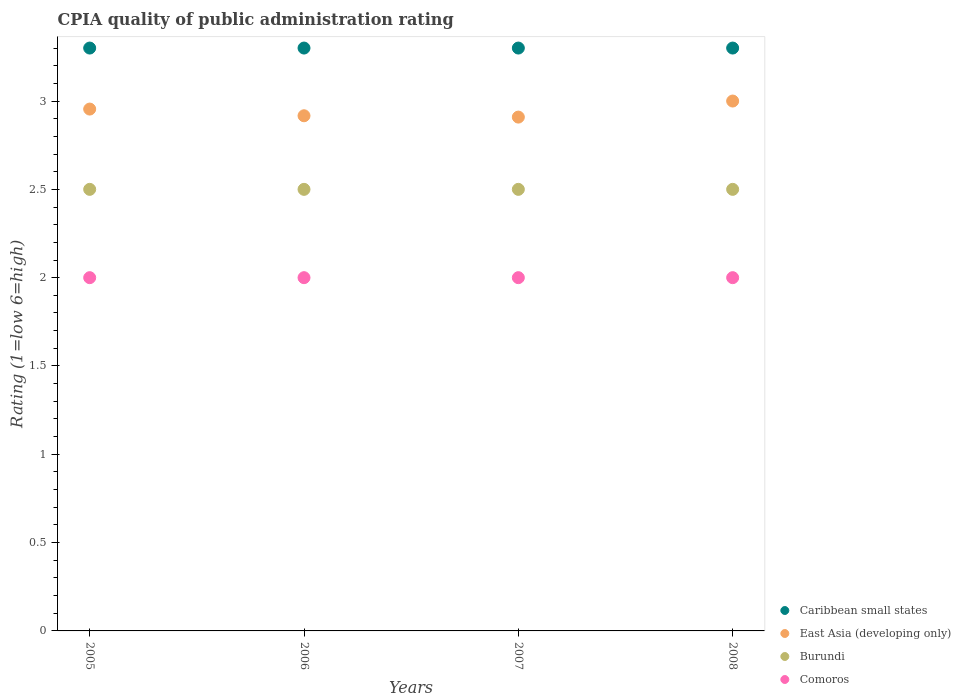Is the number of dotlines equal to the number of legend labels?
Your response must be concise. Yes. What is the CPIA rating in Comoros in 2005?
Provide a short and direct response. 2. Across all years, what is the maximum CPIA rating in East Asia (developing only)?
Make the answer very short. 3. In which year was the CPIA rating in Burundi maximum?
Offer a very short reply. 2005. In which year was the CPIA rating in Comoros minimum?
Your answer should be compact. 2005. What is the total CPIA rating in Comoros in the graph?
Provide a short and direct response. 8. What is the difference between the CPIA rating in Comoros in 2005 and the CPIA rating in Burundi in 2007?
Your response must be concise. -0.5. What is the average CPIA rating in East Asia (developing only) per year?
Give a very brief answer. 2.95. In the year 2006, what is the difference between the CPIA rating in East Asia (developing only) and CPIA rating in Caribbean small states?
Your response must be concise. -0.38. What is the ratio of the CPIA rating in Burundi in 2005 to that in 2007?
Give a very brief answer. 1. Is the CPIA rating in East Asia (developing only) in 2006 less than that in 2008?
Provide a succinct answer. Yes. Is the sum of the CPIA rating in Comoros in 2006 and 2008 greater than the maximum CPIA rating in Burundi across all years?
Ensure brevity in your answer.  Yes. Is it the case that in every year, the sum of the CPIA rating in East Asia (developing only) and CPIA rating in Caribbean small states  is greater than the sum of CPIA rating in Comoros and CPIA rating in Burundi?
Keep it short and to the point. No. Is it the case that in every year, the sum of the CPIA rating in Caribbean small states and CPIA rating in Burundi  is greater than the CPIA rating in East Asia (developing only)?
Provide a short and direct response. Yes. Is the CPIA rating in Burundi strictly less than the CPIA rating in East Asia (developing only) over the years?
Your answer should be compact. Yes. How many years are there in the graph?
Provide a short and direct response. 4. Are the values on the major ticks of Y-axis written in scientific E-notation?
Your answer should be very brief. No. Does the graph contain any zero values?
Provide a succinct answer. No. Does the graph contain grids?
Make the answer very short. No. Where does the legend appear in the graph?
Keep it short and to the point. Bottom right. How many legend labels are there?
Offer a very short reply. 4. What is the title of the graph?
Ensure brevity in your answer.  CPIA quality of public administration rating. What is the Rating (1=low 6=high) in East Asia (developing only) in 2005?
Your answer should be compact. 2.95. What is the Rating (1=low 6=high) of Comoros in 2005?
Offer a very short reply. 2. What is the Rating (1=low 6=high) in East Asia (developing only) in 2006?
Provide a succinct answer. 2.92. What is the Rating (1=low 6=high) of Caribbean small states in 2007?
Provide a succinct answer. 3.3. What is the Rating (1=low 6=high) of East Asia (developing only) in 2007?
Give a very brief answer. 2.91. What is the Rating (1=low 6=high) in Caribbean small states in 2008?
Keep it short and to the point. 3.3. What is the Rating (1=low 6=high) in East Asia (developing only) in 2008?
Make the answer very short. 3. Across all years, what is the minimum Rating (1=low 6=high) of Caribbean small states?
Give a very brief answer. 3.3. Across all years, what is the minimum Rating (1=low 6=high) of East Asia (developing only)?
Offer a very short reply. 2.91. Across all years, what is the minimum Rating (1=low 6=high) of Burundi?
Your answer should be very brief. 2.5. What is the total Rating (1=low 6=high) of East Asia (developing only) in the graph?
Provide a short and direct response. 11.78. What is the total Rating (1=low 6=high) of Burundi in the graph?
Give a very brief answer. 10. What is the total Rating (1=low 6=high) of Comoros in the graph?
Your response must be concise. 8. What is the difference between the Rating (1=low 6=high) of Caribbean small states in 2005 and that in 2006?
Your response must be concise. 0. What is the difference between the Rating (1=low 6=high) in East Asia (developing only) in 2005 and that in 2006?
Provide a succinct answer. 0.04. What is the difference between the Rating (1=low 6=high) in East Asia (developing only) in 2005 and that in 2007?
Give a very brief answer. 0.05. What is the difference between the Rating (1=low 6=high) in Burundi in 2005 and that in 2007?
Provide a succinct answer. 0. What is the difference between the Rating (1=low 6=high) of East Asia (developing only) in 2005 and that in 2008?
Your response must be concise. -0.05. What is the difference between the Rating (1=low 6=high) of Burundi in 2005 and that in 2008?
Make the answer very short. 0. What is the difference between the Rating (1=low 6=high) in Caribbean small states in 2006 and that in 2007?
Give a very brief answer. 0. What is the difference between the Rating (1=low 6=high) of East Asia (developing only) in 2006 and that in 2007?
Provide a succinct answer. 0.01. What is the difference between the Rating (1=low 6=high) of Caribbean small states in 2006 and that in 2008?
Provide a short and direct response. 0. What is the difference between the Rating (1=low 6=high) in East Asia (developing only) in 2006 and that in 2008?
Ensure brevity in your answer.  -0.08. What is the difference between the Rating (1=low 6=high) in East Asia (developing only) in 2007 and that in 2008?
Provide a succinct answer. -0.09. What is the difference between the Rating (1=low 6=high) of Comoros in 2007 and that in 2008?
Your response must be concise. 0. What is the difference between the Rating (1=low 6=high) of Caribbean small states in 2005 and the Rating (1=low 6=high) of East Asia (developing only) in 2006?
Provide a succinct answer. 0.38. What is the difference between the Rating (1=low 6=high) in Caribbean small states in 2005 and the Rating (1=low 6=high) in Burundi in 2006?
Provide a succinct answer. 0.8. What is the difference between the Rating (1=low 6=high) in East Asia (developing only) in 2005 and the Rating (1=low 6=high) in Burundi in 2006?
Offer a very short reply. 0.45. What is the difference between the Rating (1=low 6=high) in East Asia (developing only) in 2005 and the Rating (1=low 6=high) in Comoros in 2006?
Ensure brevity in your answer.  0.95. What is the difference between the Rating (1=low 6=high) of Caribbean small states in 2005 and the Rating (1=low 6=high) of East Asia (developing only) in 2007?
Provide a succinct answer. 0.39. What is the difference between the Rating (1=low 6=high) in Caribbean small states in 2005 and the Rating (1=low 6=high) in Burundi in 2007?
Your answer should be very brief. 0.8. What is the difference between the Rating (1=low 6=high) of East Asia (developing only) in 2005 and the Rating (1=low 6=high) of Burundi in 2007?
Offer a terse response. 0.45. What is the difference between the Rating (1=low 6=high) of East Asia (developing only) in 2005 and the Rating (1=low 6=high) of Comoros in 2007?
Provide a short and direct response. 0.95. What is the difference between the Rating (1=low 6=high) in Burundi in 2005 and the Rating (1=low 6=high) in Comoros in 2007?
Your response must be concise. 0.5. What is the difference between the Rating (1=low 6=high) of Caribbean small states in 2005 and the Rating (1=low 6=high) of Burundi in 2008?
Give a very brief answer. 0.8. What is the difference between the Rating (1=low 6=high) in East Asia (developing only) in 2005 and the Rating (1=low 6=high) in Burundi in 2008?
Offer a very short reply. 0.45. What is the difference between the Rating (1=low 6=high) of East Asia (developing only) in 2005 and the Rating (1=low 6=high) of Comoros in 2008?
Offer a terse response. 0.95. What is the difference between the Rating (1=low 6=high) in Burundi in 2005 and the Rating (1=low 6=high) in Comoros in 2008?
Your response must be concise. 0.5. What is the difference between the Rating (1=low 6=high) in Caribbean small states in 2006 and the Rating (1=low 6=high) in East Asia (developing only) in 2007?
Provide a short and direct response. 0.39. What is the difference between the Rating (1=low 6=high) of Caribbean small states in 2006 and the Rating (1=low 6=high) of Burundi in 2007?
Offer a terse response. 0.8. What is the difference between the Rating (1=low 6=high) of Caribbean small states in 2006 and the Rating (1=low 6=high) of Comoros in 2007?
Keep it short and to the point. 1.3. What is the difference between the Rating (1=low 6=high) of East Asia (developing only) in 2006 and the Rating (1=low 6=high) of Burundi in 2007?
Give a very brief answer. 0.42. What is the difference between the Rating (1=low 6=high) of East Asia (developing only) in 2006 and the Rating (1=low 6=high) of Comoros in 2007?
Provide a short and direct response. 0.92. What is the difference between the Rating (1=low 6=high) in Burundi in 2006 and the Rating (1=low 6=high) in Comoros in 2007?
Offer a terse response. 0.5. What is the difference between the Rating (1=low 6=high) of Caribbean small states in 2006 and the Rating (1=low 6=high) of Burundi in 2008?
Provide a succinct answer. 0.8. What is the difference between the Rating (1=low 6=high) of Caribbean small states in 2006 and the Rating (1=low 6=high) of Comoros in 2008?
Provide a succinct answer. 1.3. What is the difference between the Rating (1=low 6=high) of East Asia (developing only) in 2006 and the Rating (1=low 6=high) of Burundi in 2008?
Your answer should be compact. 0.42. What is the difference between the Rating (1=low 6=high) of Caribbean small states in 2007 and the Rating (1=low 6=high) of East Asia (developing only) in 2008?
Provide a succinct answer. 0.3. What is the difference between the Rating (1=low 6=high) in East Asia (developing only) in 2007 and the Rating (1=low 6=high) in Burundi in 2008?
Provide a short and direct response. 0.41. What is the difference between the Rating (1=low 6=high) in East Asia (developing only) in 2007 and the Rating (1=low 6=high) in Comoros in 2008?
Provide a succinct answer. 0.91. What is the average Rating (1=low 6=high) of East Asia (developing only) per year?
Make the answer very short. 2.95. What is the average Rating (1=low 6=high) in Burundi per year?
Ensure brevity in your answer.  2.5. What is the average Rating (1=low 6=high) in Comoros per year?
Your answer should be compact. 2. In the year 2005, what is the difference between the Rating (1=low 6=high) in Caribbean small states and Rating (1=low 6=high) in East Asia (developing only)?
Provide a succinct answer. 0.35. In the year 2005, what is the difference between the Rating (1=low 6=high) of Caribbean small states and Rating (1=low 6=high) of Burundi?
Offer a terse response. 0.8. In the year 2005, what is the difference between the Rating (1=low 6=high) of Caribbean small states and Rating (1=low 6=high) of Comoros?
Provide a short and direct response. 1.3. In the year 2005, what is the difference between the Rating (1=low 6=high) of East Asia (developing only) and Rating (1=low 6=high) of Burundi?
Give a very brief answer. 0.45. In the year 2005, what is the difference between the Rating (1=low 6=high) in East Asia (developing only) and Rating (1=low 6=high) in Comoros?
Provide a succinct answer. 0.95. In the year 2006, what is the difference between the Rating (1=low 6=high) of Caribbean small states and Rating (1=low 6=high) of East Asia (developing only)?
Offer a very short reply. 0.38. In the year 2006, what is the difference between the Rating (1=low 6=high) in East Asia (developing only) and Rating (1=low 6=high) in Burundi?
Your answer should be very brief. 0.42. In the year 2006, what is the difference between the Rating (1=low 6=high) of East Asia (developing only) and Rating (1=low 6=high) of Comoros?
Provide a succinct answer. 0.92. In the year 2007, what is the difference between the Rating (1=low 6=high) in Caribbean small states and Rating (1=low 6=high) in East Asia (developing only)?
Provide a short and direct response. 0.39. In the year 2007, what is the difference between the Rating (1=low 6=high) of Caribbean small states and Rating (1=low 6=high) of Comoros?
Offer a terse response. 1.3. In the year 2007, what is the difference between the Rating (1=low 6=high) in East Asia (developing only) and Rating (1=low 6=high) in Burundi?
Keep it short and to the point. 0.41. In the year 2007, what is the difference between the Rating (1=low 6=high) of East Asia (developing only) and Rating (1=low 6=high) of Comoros?
Your response must be concise. 0.91. In the year 2008, what is the difference between the Rating (1=low 6=high) of Burundi and Rating (1=low 6=high) of Comoros?
Provide a succinct answer. 0.5. What is the ratio of the Rating (1=low 6=high) of Burundi in 2005 to that in 2006?
Your answer should be very brief. 1. What is the ratio of the Rating (1=low 6=high) in Comoros in 2005 to that in 2006?
Your answer should be compact. 1. What is the ratio of the Rating (1=low 6=high) of East Asia (developing only) in 2005 to that in 2007?
Offer a terse response. 1.02. What is the ratio of the Rating (1=low 6=high) of Burundi in 2005 to that in 2007?
Provide a short and direct response. 1. What is the ratio of the Rating (1=low 6=high) in Comoros in 2005 to that in 2007?
Provide a succinct answer. 1. What is the ratio of the Rating (1=low 6=high) in Caribbean small states in 2005 to that in 2008?
Ensure brevity in your answer.  1. What is the ratio of the Rating (1=low 6=high) in East Asia (developing only) in 2005 to that in 2008?
Offer a terse response. 0.98. What is the ratio of the Rating (1=low 6=high) of Burundi in 2005 to that in 2008?
Give a very brief answer. 1. What is the ratio of the Rating (1=low 6=high) in Comoros in 2005 to that in 2008?
Keep it short and to the point. 1. What is the ratio of the Rating (1=low 6=high) in Caribbean small states in 2006 to that in 2007?
Provide a short and direct response. 1. What is the ratio of the Rating (1=low 6=high) of Caribbean small states in 2006 to that in 2008?
Make the answer very short. 1. What is the ratio of the Rating (1=low 6=high) in East Asia (developing only) in 2006 to that in 2008?
Keep it short and to the point. 0.97. What is the ratio of the Rating (1=low 6=high) of Burundi in 2006 to that in 2008?
Give a very brief answer. 1. What is the ratio of the Rating (1=low 6=high) of East Asia (developing only) in 2007 to that in 2008?
Keep it short and to the point. 0.97. What is the ratio of the Rating (1=low 6=high) in Burundi in 2007 to that in 2008?
Keep it short and to the point. 1. What is the ratio of the Rating (1=low 6=high) of Comoros in 2007 to that in 2008?
Provide a short and direct response. 1. What is the difference between the highest and the second highest Rating (1=low 6=high) of Caribbean small states?
Your answer should be compact. 0. What is the difference between the highest and the second highest Rating (1=low 6=high) in East Asia (developing only)?
Offer a terse response. 0.05. What is the difference between the highest and the lowest Rating (1=low 6=high) in East Asia (developing only)?
Make the answer very short. 0.09. What is the difference between the highest and the lowest Rating (1=low 6=high) in Comoros?
Offer a very short reply. 0. 